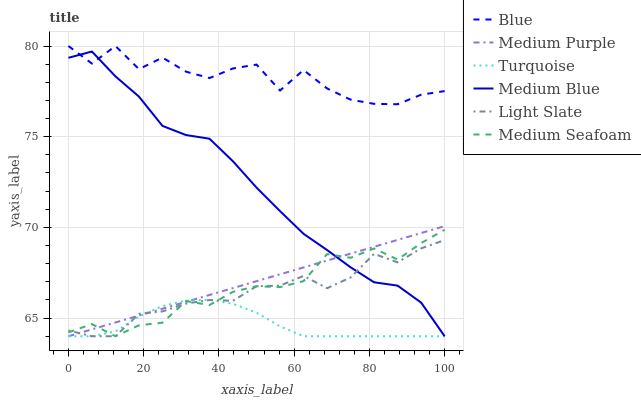Does Turquoise have the minimum area under the curve?
Answer yes or no. Yes. Does Blue have the maximum area under the curve?
Answer yes or no. Yes. Does Light Slate have the minimum area under the curve?
Answer yes or no. No. Does Light Slate have the maximum area under the curve?
Answer yes or no. No. Is Medium Purple the smoothest?
Answer yes or no. Yes. Is Blue the roughest?
Answer yes or no. Yes. Is Turquoise the smoothest?
Answer yes or no. No. Is Turquoise the roughest?
Answer yes or no. No. Does Blue have the highest value?
Answer yes or no. Yes. Does Light Slate have the highest value?
Answer yes or no. No. Is Medium Purple less than Blue?
Answer yes or no. Yes. Is Blue greater than Medium Seafoam?
Answer yes or no. Yes. Does Medium Seafoam intersect Medium Purple?
Answer yes or no. Yes. Is Medium Seafoam less than Medium Purple?
Answer yes or no. No. Is Medium Seafoam greater than Medium Purple?
Answer yes or no. No. Does Medium Purple intersect Blue?
Answer yes or no. No. 